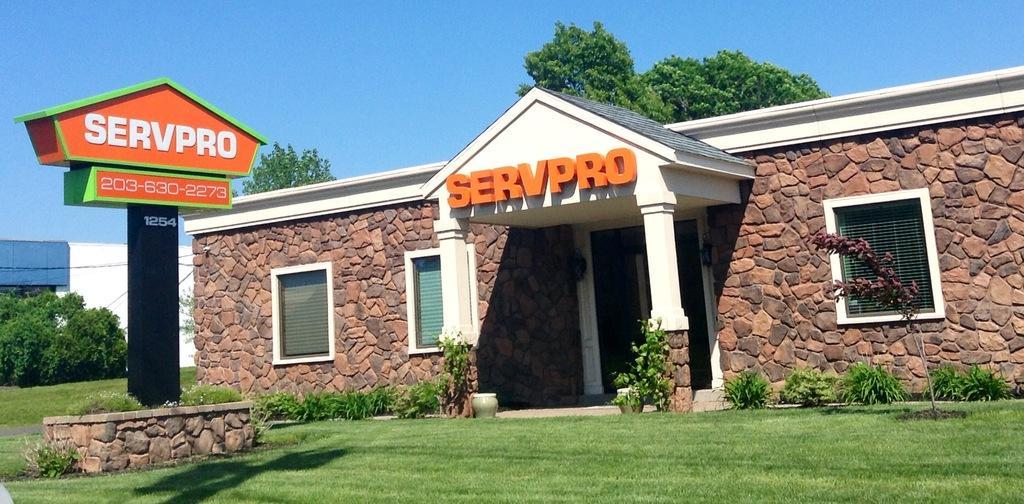Can you describe this image briefly? In this image we can see a building with windows and pillars. And there is a name on the building. In front of the building there are plants and grass. And there is a stand with name boards. In the background there are trees. Also there is sky. And there is another building. 